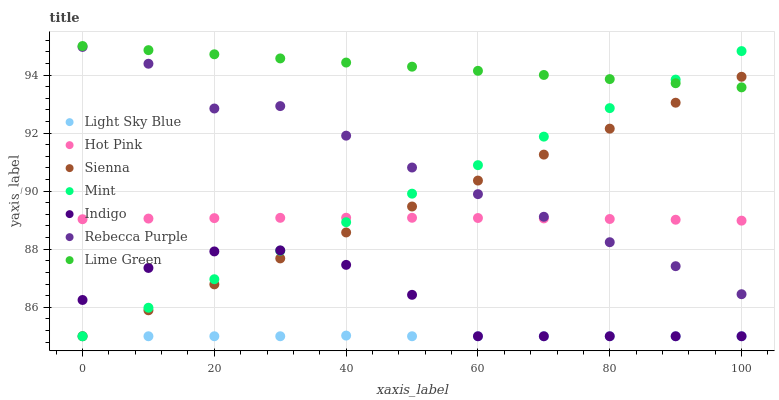Does Light Sky Blue have the minimum area under the curve?
Answer yes or no. Yes. Does Lime Green have the maximum area under the curve?
Answer yes or no. Yes. Does Hot Pink have the minimum area under the curve?
Answer yes or no. No. Does Hot Pink have the maximum area under the curve?
Answer yes or no. No. Is Mint the smoothest?
Answer yes or no. Yes. Is Rebecca Purple the roughest?
Answer yes or no. Yes. Is Lime Green the smoothest?
Answer yes or no. No. Is Lime Green the roughest?
Answer yes or no. No. Does Indigo have the lowest value?
Answer yes or no. Yes. Does Hot Pink have the lowest value?
Answer yes or no. No. Does Lime Green have the highest value?
Answer yes or no. Yes. Does Hot Pink have the highest value?
Answer yes or no. No. Is Light Sky Blue less than Hot Pink?
Answer yes or no. Yes. Is Lime Green greater than Rebecca Purple?
Answer yes or no. Yes. Does Sienna intersect Rebecca Purple?
Answer yes or no. Yes. Is Sienna less than Rebecca Purple?
Answer yes or no. No. Is Sienna greater than Rebecca Purple?
Answer yes or no. No. Does Light Sky Blue intersect Hot Pink?
Answer yes or no. No. 